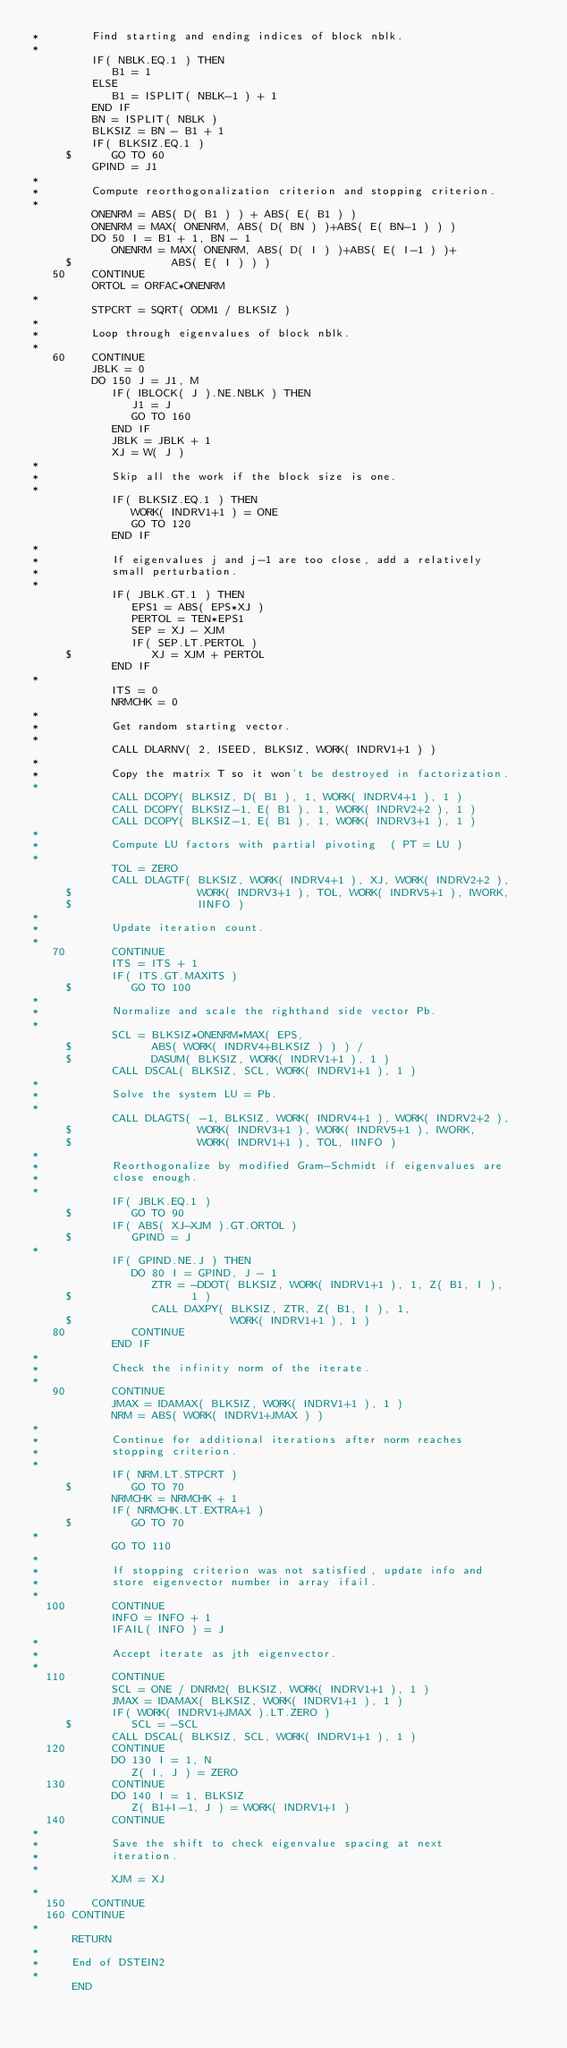<code> <loc_0><loc_0><loc_500><loc_500><_FORTRAN_>*        Find starting and ending indices of block nblk.
*
         IF( NBLK.EQ.1 ) THEN
            B1 = 1
         ELSE
            B1 = ISPLIT( NBLK-1 ) + 1
         END IF
         BN = ISPLIT( NBLK )
         BLKSIZ = BN - B1 + 1
         IF( BLKSIZ.EQ.1 )
     $      GO TO 60
         GPIND = J1
*
*        Compute reorthogonalization criterion and stopping criterion.
*
         ONENRM = ABS( D( B1 ) ) + ABS( E( B1 ) )
         ONENRM = MAX( ONENRM, ABS( D( BN ) )+ABS( E( BN-1 ) ) )
         DO 50 I = B1 + 1, BN - 1
            ONENRM = MAX( ONENRM, ABS( D( I ) )+ABS( E( I-1 ) )+
     $               ABS( E( I ) ) )
   50    CONTINUE
         ORTOL = ORFAC*ONENRM
*
         STPCRT = SQRT( ODM1 / BLKSIZ )
*
*        Loop through eigenvalues of block nblk.
*
   60    CONTINUE
         JBLK = 0
         DO 150 J = J1, M
            IF( IBLOCK( J ).NE.NBLK ) THEN
               J1 = J
               GO TO 160
            END IF
            JBLK = JBLK + 1
            XJ = W( J )
*
*           Skip all the work if the block size is one.
*
            IF( BLKSIZ.EQ.1 ) THEN
               WORK( INDRV1+1 ) = ONE
               GO TO 120
            END IF
*
*           If eigenvalues j and j-1 are too close, add a relatively
*           small perturbation.
*
            IF( JBLK.GT.1 ) THEN
               EPS1 = ABS( EPS*XJ )
               PERTOL = TEN*EPS1
               SEP = XJ - XJM
               IF( SEP.LT.PERTOL )
     $            XJ = XJM + PERTOL
            END IF
*
            ITS = 0
            NRMCHK = 0
*
*           Get random starting vector.
*
            CALL DLARNV( 2, ISEED, BLKSIZ, WORK( INDRV1+1 ) )
*
*           Copy the matrix T so it won't be destroyed in factorization.
*
            CALL DCOPY( BLKSIZ, D( B1 ), 1, WORK( INDRV4+1 ), 1 )
            CALL DCOPY( BLKSIZ-1, E( B1 ), 1, WORK( INDRV2+2 ), 1 )
            CALL DCOPY( BLKSIZ-1, E( B1 ), 1, WORK( INDRV3+1 ), 1 )
*
*           Compute LU factors with partial pivoting  ( PT = LU )
*
            TOL = ZERO
            CALL DLAGTF( BLKSIZ, WORK( INDRV4+1 ), XJ, WORK( INDRV2+2 ),
     $                   WORK( INDRV3+1 ), TOL, WORK( INDRV5+1 ), IWORK,
     $                   IINFO )
*
*           Update iteration count.
*
   70       CONTINUE
            ITS = ITS + 1
            IF( ITS.GT.MAXITS )
     $         GO TO 100
*
*           Normalize and scale the righthand side vector Pb.
*
            SCL = BLKSIZ*ONENRM*MAX( EPS,
     $            ABS( WORK( INDRV4+BLKSIZ ) ) ) /
     $            DASUM( BLKSIZ, WORK( INDRV1+1 ), 1 )
            CALL DSCAL( BLKSIZ, SCL, WORK( INDRV1+1 ), 1 )
*
*           Solve the system LU = Pb.
*
            CALL DLAGTS( -1, BLKSIZ, WORK( INDRV4+1 ), WORK( INDRV2+2 ),
     $                   WORK( INDRV3+1 ), WORK( INDRV5+1 ), IWORK,
     $                   WORK( INDRV1+1 ), TOL, IINFO )
*
*           Reorthogonalize by modified Gram-Schmidt if eigenvalues are
*           close enough.
*
            IF( JBLK.EQ.1 )
     $         GO TO 90
            IF( ABS( XJ-XJM ).GT.ORTOL )
     $         GPIND = J
*
            IF( GPIND.NE.J ) THEN
               DO 80 I = GPIND, J - 1
                  ZTR = -DDOT( BLKSIZ, WORK( INDRV1+1 ), 1, Z( B1, I ),
     $                  1 )
                  CALL DAXPY( BLKSIZ, ZTR, Z( B1, I ), 1,
     $                        WORK( INDRV1+1 ), 1 )
   80          CONTINUE
            END IF
*
*           Check the infinity norm of the iterate.
*
   90       CONTINUE
            JMAX = IDAMAX( BLKSIZ, WORK( INDRV1+1 ), 1 )
            NRM = ABS( WORK( INDRV1+JMAX ) )
*
*           Continue for additional iterations after norm reaches
*           stopping criterion.
*
            IF( NRM.LT.STPCRT )
     $         GO TO 70
            NRMCHK = NRMCHK + 1
            IF( NRMCHK.LT.EXTRA+1 )
     $         GO TO 70
*
            GO TO 110
*
*           If stopping criterion was not satisfied, update info and
*           store eigenvector number in array ifail.
*
  100       CONTINUE
            INFO = INFO + 1
            IFAIL( INFO ) = J
*
*           Accept iterate as jth eigenvector.
*
  110       CONTINUE
            SCL = ONE / DNRM2( BLKSIZ, WORK( INDRV1+1 ), 1 )
            JMAX = IDAMAX( BLKSIZ, WORK( INDRV1+1 ), 1 )
            IF( WORK( INDRV1+JMAX ).LT.ZERO )
     $         SCL = -SCL
            CALL DSCAL( BLKSIZ, SCL, WORK( INDRV1+1 ), 1 )
  120       CONTINUE
            DO 130 I = 1, N
               Z( I, J ) = ZERO
  130       CONTINUE
            DO 140 I = 1, BLKSIZ
               Z( B1+I-1, J ) = WORK( INDRV1+I )
  140       CONTINUE
*
*           Save the shift to check eigenvalue spacing at next
*           iteration.
*
            XJM = XJ
*
  150    CONTINUE
  160 CONTINUE
*
      RETURN
*
*     End of DSTEIN2
*
      END
</code> 